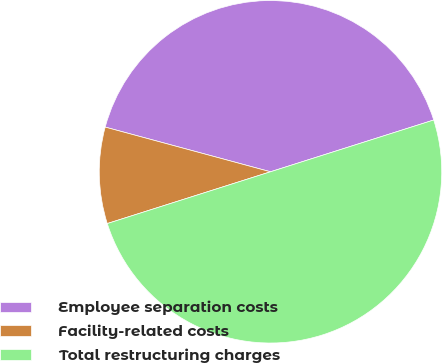Convert chart to OTSL. <chart><loc_0><loc_0><loc_500><loc_500><pie_chart><fcel>Employee separation costs<fcel>Facility-related costs<fcel>Total restructuring charges<nl><fcel>40.91%<fcel>9.09%<fcel>50.0%<nl></chart> 